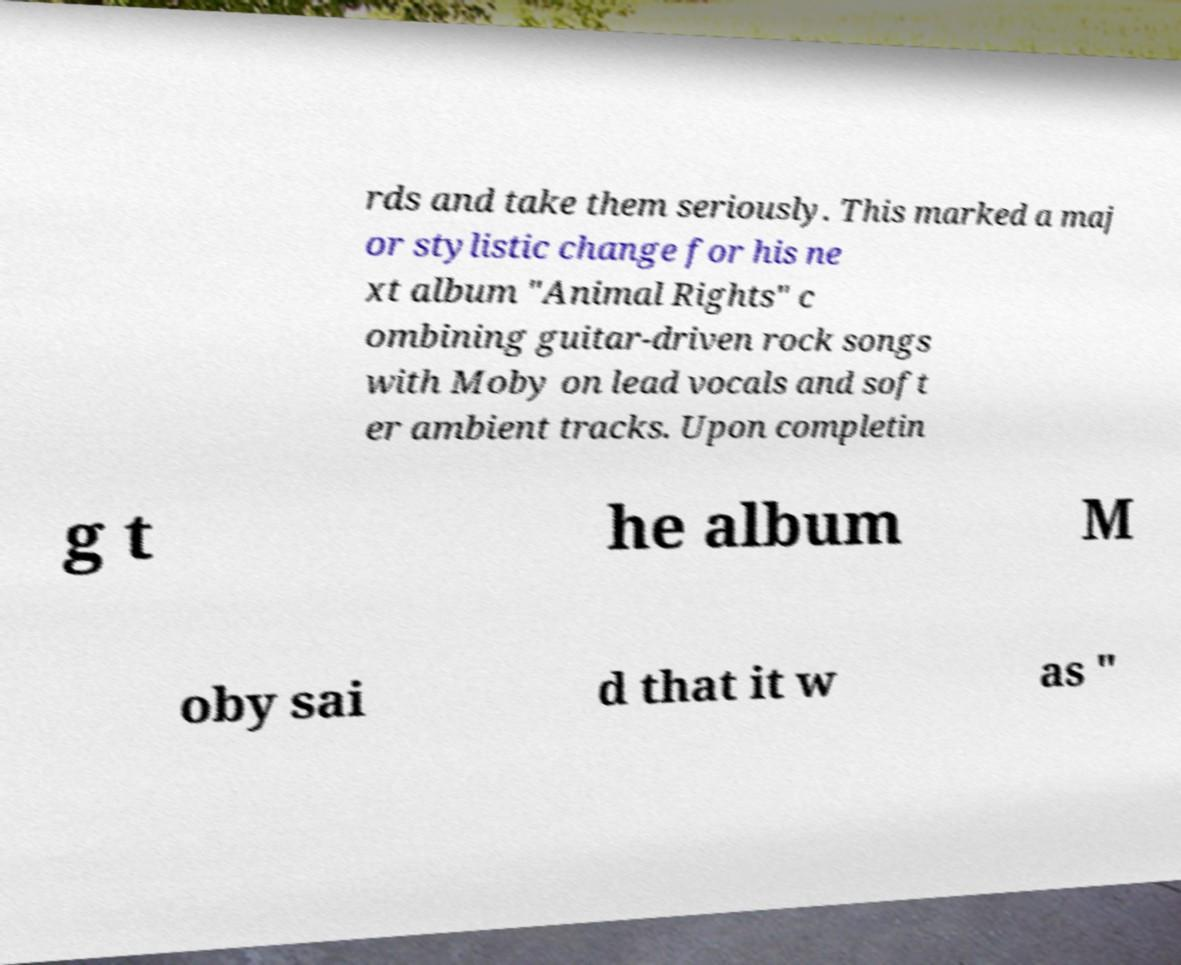What messages or text are displayed in this image? I need them in a readable, typed format. rds and take them seriously. This marked a maj or stylistic change for his ne xt album "Animal Rights" c ombining guitar-driven rock songs with Moby on lead vocals and soft er ambient tracks. Upon completin g t he album M oby sai d that it w as " 